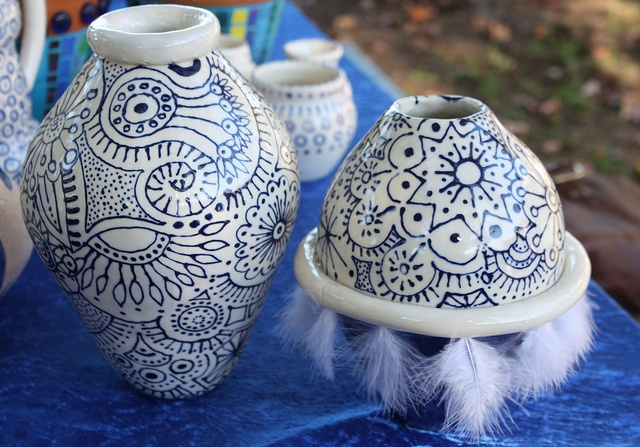Describe the objects in this image and their specific colors. I can see vase in lightgray, darkgray, gray, and navy tones, vase in lightgray, darkgray, and gray tones, vase in lightgray, darkgray, and gray tones, vase in lightgray and darkgray tones, and vase in lightgray, darkgray, and gray tones in this image. 